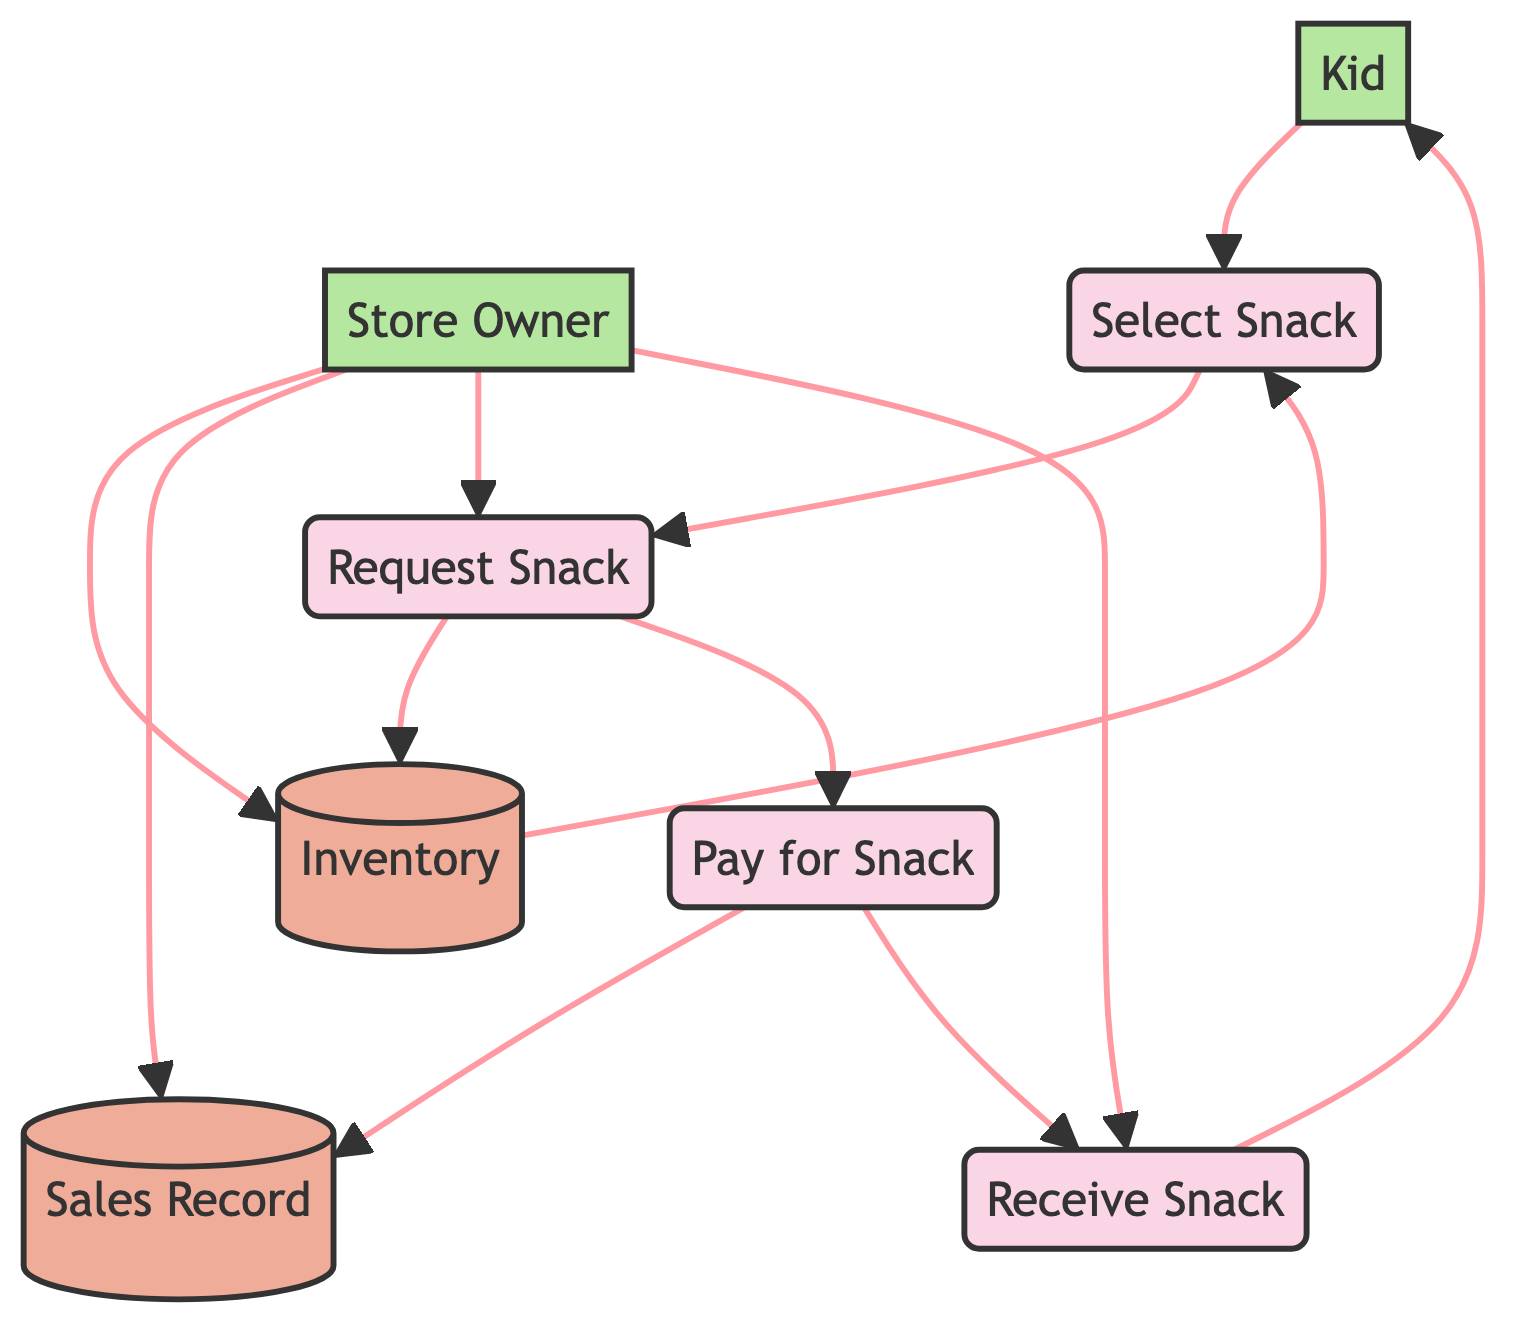What is the name of the first process in the diagram? The first process is labeled as "Select Snack," as indicated in the diagram.
Answer: Select Snack How many processes are represented in the diagram? The diagram lists four processes: Select Snack, Request Snack, Pay for Snack, and Receive Snack. Therefore, there are four processes in total.
Answer: Four Who is the external entity that represents the person buying the snack? The external entity representing the person buying the snack is labeled as "Kid" in the diagram.
Answer: Kid What data store is updated when a snack is requested? The data store updated when a snack is requested is "Inventory" as it marks the requested snack as sold.
Answer: Inventory Which process confirms the payment completion? The "Pay for Snack" process confirms the payment completion before the kid can receive the snack.
Answer: Pay for Snack What flow connects the "Pay for Snack" process to the "Sales Record" data store? The flow that connects the "Pay for Snack" process to the "Sales Record" data store is labeled as "F5." This flow records the payment details.
Answer: F5 How many data stores are present in the diagram? There are two data stores present, which are Inventory and Sales Record.
Answer: Two Which external entity manages inventory and transactions? The external entity that manages inventory and transactions is labeled as "Store Owner" in the diagram.
Answer: Store Owner What is the last step in the daily snack purchase process? The last step in the process is "Receive Snack," which is when the kid receives the snack after completing payment.
Answer: Receive Snack 